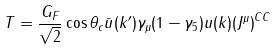Convert formula to latex. <formula><loc_0><loc_0><loc_500><loc_500>T = \frac { G _ { F } } { \sqrt { 2 } } \cos { \theta _ { c } } \bar { u } ( k ^ { \prime } ) \gamma _ { \mu } ( 1 - \gamma _ { 5 } ) u ( k ) { ( J ^ { \mu } ) } ^ { C C }</formula> 